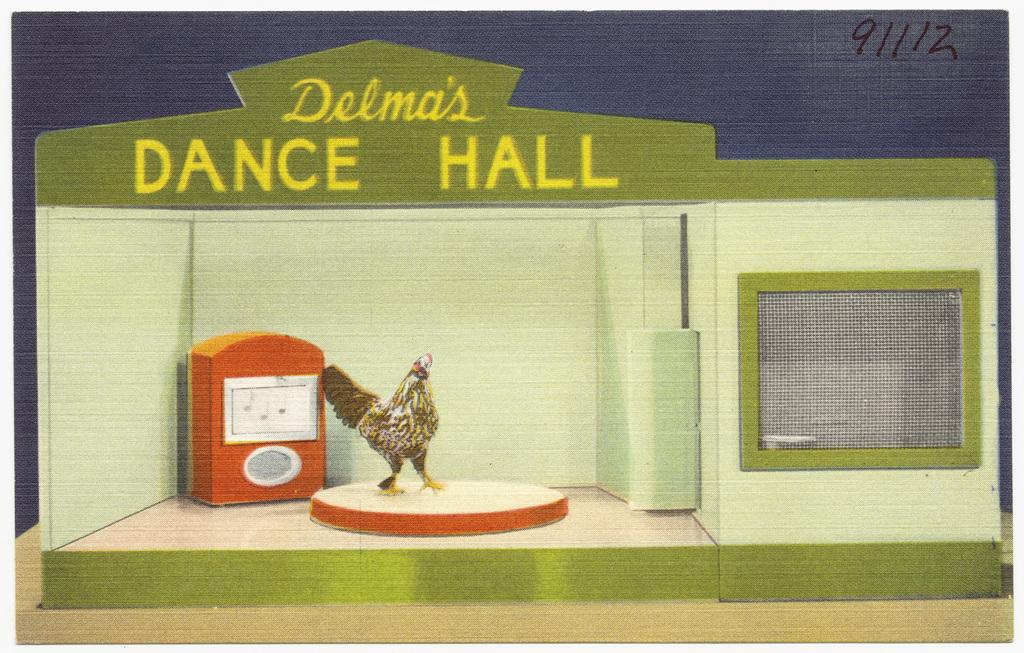What is the main subject in the center of the image? There is a poster in the center of the image. What animal can be seen on a circular surface in the image? There is a hen on a circular surface in the image. What can be seen on the right side of the image? There is a window on the right side of the image. What else is present in the image besides the poster, hen, and window? There are other objects in the image. Where is the text located in the image? The text is at the top side of the image. Where is the sink located in the image? There is no sink present in the image. What type of board is being used by the hen in the image? There is no board present in the image; the hen is on a circular surface. 